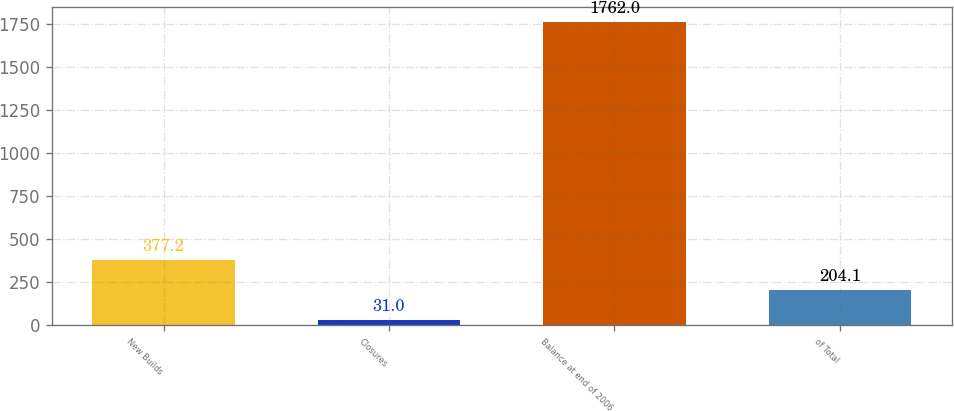Convert chart to OTSL. <chart><loc_0><loc_0><loc_500><loc_500><bar_chart><fcel>New Builds<fcel>Closures<fcel>Balance at end of 2006<fcel>of Total<nl><fcel>377.2<fcel>31<fcel>1762<fcel>204.1<nl></chart> 